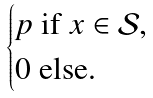Convert formula to latex. <formula><loc_0><loc_0><loc_500><loc_500>\begin{cases} p \text { if $x \in \mathcal{S}$,} \\ 0 \text { else.} \end{cases}</formula> 